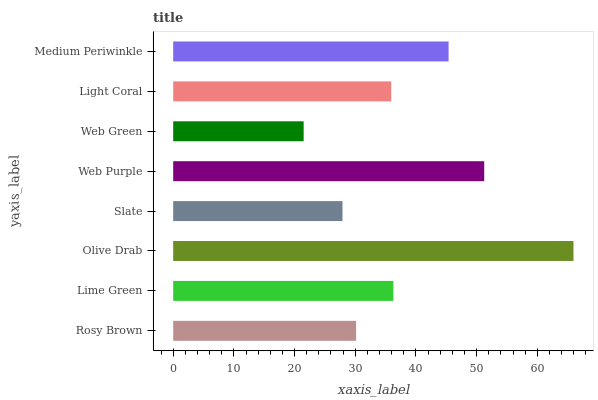Is Web Green the minimum?
Answer yes or no. Yes. Is Olive Drab the maximum?
Answer yes or no. Yes. Is Lime Green the minimum?
Answer yes or no. No. Is Lime Green the maximum?
Answer yes or no. No. Is Lime Green greater than Rosy Brown?
Answer yes or no. Yes. Is Rosy Brown less than Lime Green?
Answer yes or no. Yes. Is Rosy Brown greater than Lime Green?
Answer yes or no. No. Is Lime Green less than Rosy Brown?
Answer yes or no. No. Is Lime Green the high median?
Answer yes or no. Yes. Is Light Coral the low median?
Answer yes or no. Yes. Is Light Coral the high median?
Answer yes or no. No. Is Slate the low median?
Answer yes or no. No. 